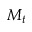Convert formula to latex. <formula><loc_0><loc_0><loc_500><loc_500>M _ { t }</formula> 